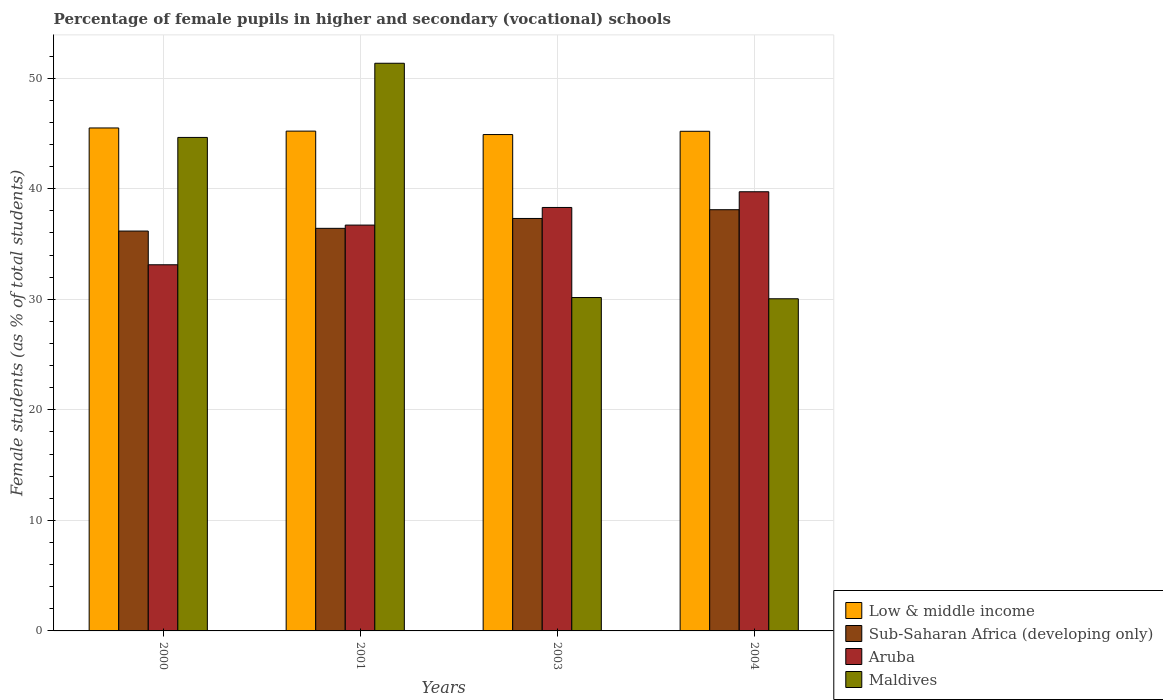How many groups of bars are there?
Keep it short and to the point. 4. Are the number of bars on each tick of the X-axis equal?
Your answer should be very brief. Yes. How many bars are there on the 4th tick from the right?
Offer a terse response. 4. What is the percentage of female pupils in higher and secondary schools in Maldives in 2004?
Your response must be concise. 30.04. Across all years, what is the maximum percentage of female pupils in higher and secondary schools in Aruba?
Your answer should be compact. 39.72. Across all years, what is the minimum percentage of female pupils in higher and secondary schools in Sub-Saharan Africa (developing only)?
Offer a very short reply. 36.17. What is the total percentage of female pupils in higher and secondary schools in Aruba in the graph?
Provide a short and direct response. 147.86. What is the difference between the percentage of female pupils in higher and secondary schools in Aruba in 2003 and that in 2004?
Your response must be concise. -1.42. What is the difference between the percentage of female pupils in higher and secondary schools in Maldives in 2003 and the percentage of female pupils in higher and secondary schools in Sub-Saharan Africa (developing only) in 2001?
Give a very brief answer. -6.26. What is the average percentage of female pupils in higher and secondary schools in Low & middle income per year?
Offer a terse response. 45.2. In the year 2003, what is the difference between the percentage of female pupils in higher and secondary schools in Maldives and percentage of female pupils in higher and secondary schools in Aruba?
Offer a terse response. -8.15. What is the ratio of the percentage of female pupils in higher and secondary schools in Aruba in 2001 to that in 2004?
Offer a terse response. 0.92. What is the difference between the highest and the second highest percentage of female pupils in higher and secondary schools in Maldives?
Keep it short and to the point. 6.71. What is the difference between the highest and the lowest percentage of female pupils in higher and secondary schools in Low & middle income?
Provide a short and direct response. 0.6. Is the sum of the percentage of female pupils in higher and secondary schools in Sub-Saharan Africa (developing only) in 2000 and 2003 greater than the maximum percentage of female pupils in higher and secondary schools in Maldives across all years?
Offer a terse response. Yes. Is it the case that in every year, the sum of the percentage of female pupils in higher and secondary schools in Maldives and percentage of female pupils in higher and secondary schools in Sub-Saharan Africa (developing only) is greater than the sum of percentage of female pupils in higher and secondary schools in Aruba and percentage of female pupils in higher and secondary schools in Low & middle income?
Offer a very short reply. No. What does the 3rd bar from the left in 2003 represents?
Your response must be concise. Aruba. What does the 2nd bar from the right in 2001 represents?
Provide a succinct answer. Aruba. Is it the case that in every year, the sum of the percentage of female pupils in higher and secondary schools in Maldives and percentage of female pupils in higher and secondary schools in Low & middle income is greater than the percentage of female pupils in higher and secondary schools in Aruba?
Offer a terse response. Yes. How many years are there in the graph?
Provide a short and direct response. 4. Does the graph contain grids?
Make the answer very short. Yes. How many legend labels are there?
Make the answer very short. 4. How are the legend labels stacked?
Offer a very short reply. Vertical. What is the title of the graph?
Offer a terse response. Percentage of female pupils in higher and secondary (vocational) schools. What is the label or title of the X-axis?
Keep it short and to the point. Years. What is the label or title of the Y-axis?
Offer a very short reply. Female students (as % of total students). What is the Female students (as % of total students) of Low & middle income in 2000?
Your answer should be compact. 45.5. What is the Female students (as % of total students) in Sub-Saharan Africa (developing only) in 2000?
Provide a short and direct response. 36.17. What is the Female students (as % of total students) in Aruba in 2000?
Ensure brevity in your answer.  33.12. What is the Female students (as % of total students) in Maldives in 2000?
Provide a short and direct response. 44.64. What is the Female students (as % of total students) in Low & middle income in 2001?
Provide a short and direct response. 45.21. What is the Female students (as % of total students) in Sub-Saharan Africa (developing only) in 2001?
Offer a terse response. 36.42. What is the Female students (as % of total students) in Aruba in 2001?
Provide a succinct answer. 36.71. What is the Female students (as % of total students) of Maldives in 2001?
Ensure brevity in your answer.  51.35. What is the Female students (as % of total students) in Low & middle income in 2003?
Offer a very short reply. 44.9. What is the Female students (as % of total students) of Sub-Saharan Africa (developing only) in 2003?
Provide a short and direct response. 37.31. What is the Female students (as % of total students) of Aruba in 2003?
Your answer should be very brief. 38.3. What is the Female students (as % of total students) in Maldives in 2003?
Offer a terse response. 30.16. What is the Female students (as % of total students) in Low & middle income in 2004?
Offer a very short reply. 45.19. What is the Female students (as % of total students) in Sub-Saharan Africa (developing only) in 2004?
Offer a very short reply. 38.1. What is the Female students (as % of total students) in Aruba in 2004?
Give a very brief answer. 39.72. What is the Female students (as % of total students) in Maldives in 2004?
Give a very brief answer. 30.04. Across all years, what is the maximum Female students (as % of total students) in Low & middle income?
Your answer should be very brief. 45.5. Across all years, what is the maximum Female students (as % of total students) in Sub-Saharan Africa (developing only)?
Your response must be concise. 38.1. Across all years, what is the maximum Female students (as % of total students) of Aruba?
Ensure brevity in your answer.  39.72. Across all years, what is the maximum Female students (as % of total students) of Maldives?
Your response must be concise. 51.35. Across all years, what is the minimum Female students (as % of total students) in Low & middle income?
Your answer should be very brief. 44.9. Across all years, what is the minimum Female students (as % of total students) in Sub-Saharan Africa (developing only)?
Give a very brief answer. 36.17. Across all years, what is the minimum Female students (as % of total students) of Aruba?
Offer a very short reply. 33.12. Across all years, what is the minimum Female students (as % of total students) of Maldives?
Offer a terse response. 30.04. What is the total Female students (as % of total students) in Low & middle income in the graph?
Offer a terse response. 180.8. What is the total Female students (as % of total students) in Sub-Saharan Africa (developing only) in the graph?
Provide a succinct answer. 147.99. What is the total Female students (as % of total students) in Aruba in the graph?
Your answer should be compact. 147.86. What is the total Female students (as % of total students) in Maldives in the graph?
Your response must be concise. 156.19. What is the difference between the Female students (as % of total students) in Low & middle income in 2000 and that in 2001?
Ensure brevity in your answer.  0.29. What is the difference between the Female students (as % of total students) of Sub-Saharan Africa (developing only) in 2000 and that in 2001?
Your response must be concise. -0.25. What is the difference between the Female students (as % of total students) in Aruba in 2000 and that in 2001?
Your answer should be very brief. -3.59. What is the difference between the Female students (as % of total students) of Maldives in 2000 and that in 2001?
Your answer should be compact. -6.71. What is the difference between the Female students (as % of total students) of Low & middle income in 2000 and that in 2003?
Your response must be concise. 0.6. What is the difference between the Female students (as % of total students) of Sub-Saharan Africa (developing only) in 2000 and that in 2003?
Your response must be concise. -1.14. What is the difference between the Female students (as % of total students) in Aruba in 2000 and that in 2003?
Your response must be concise. -5.18. What is the difference between the Female students (as % of total students) of Maldives in 2000 and that in 2003?
Your answer should be very brief. 14.48. What is the difference between the Female students (as % of total students) in Low & middle income in 2000 and that in 2004?
Give a very brief answer. 0.3. What is the difference between the Female students (as % of total students) of Sub-Saharan Africa (developing only) in 2000 and that in 2004?
Your answer should be very brief. -1.93. What is the difference between the Female students (as % of total students) of Aruba in 2000 and that in 2004?
Keep it short and to the point. -6.6. What is the difference between the Female students (as % of total students) of Maldives in 2000 and that in 2004?
Provide a succinct answer. 14.59. What is the difference between the Female students (as % of total students) in Low & middle income in 2001 and that in 2003?
Offer a terse response. 0.31. What is the difference between the Female students (as % of total students) in Sub-Saharan Africa (developing only) in 2001 and that in 2003?
Your response must be concise. -0.89. What is the difference between the Female students (as % of total students) of Aruba in 2001 and that in 2003?
Provide a short and direct response. -1.59. What is the difference between the Female students (as % of total students) of Maldives in 2001 and that in 2003?
Your response must be concise. 21.19. What is the difference between the Female students (as % of total students) in Low & middle income in 2001 and that in 2004?
Ensure brevity in your answer.  0.02. What is the difference between the Female students (as % of total students) of Sub-Saharan Africa (developing only) in 2001 and that in 2004?
Provide a succinct answer. -1.68. What is the difference between the Female students (as % of total students) of Aruba in 2001 and that in 2004?
Keep it short and to the point. -3.01. What is the difference between the Female students (as % of total students) in Maldives in 2001 and that in 2004?
Your answer should be compact. 21.3. What is the difference between the Female students (as % of total students) of Low & middle income in 2003 and that in 2004?
Keep it short and to the point. -0.29. What is the difference between the Female students (as % of total students) of Sub-Saharan Africa (developing only) in 2003 and that in 2004?
Offer a very short reply. -0.79. What is the difference between the Female students (as % of total students) in Aruba in 2003 and that in 2004?
Ensure brevity in your answer.  -1.42. What is the difference between the Female students (as % of total students) in Maldives in 2003 and that in 2004?
Keep it short and to the point. 0.11. What is the difference between the Female students (as % of total students) in Low & middle income in 2000 and the Female students (as % of total students) in Sub-Saharan Africa (developing only) in 2001?
Make the answer very short. 9.08. What is the difference between the Female students (as % of total students) of Low & middle income in 2000 and the Female students (as % of total students) of Aruba in 2001?
Keep it short and to the point. 8.79. What is the difference between the Female students (as % of total students) in Low & middle income in 2000 and the Female students (as % of total students) in Maldives in 2001?
Offer a very short reply. -5.85. What is the difference between the Female students (as % of total students) of Sub-Saharan Africa (developing only) in 2000 and the Female students (as % of total students) of Aruba in 2001?
Provide a succinct answer. -0.54. What is the difference between the Female students (as % of total students) of Sub-Saharan Africa (developing only) in 2000 and the Female students (as % of total students) of Maldives in 2001?
Provide a short and direct response. -15.18. What is the difference between the Female students (as % of total students) in Aruba in 2000 and the Female students (as % of total students) in Maldives in 2001?
Your answer should be very brief. -18.23. What is the difference between the Female students (as % of total students) of Low & middle income in 2000 and the Female students (as % of total students) of Sub-Saharan Africa (developing only) in 2003?
Your answer should be very brief. 8.19. What is the difference between the Female students (as % of total students) in Low & middle income in 2000 and the Female students (as % of total students) in Aruba in 2003?
Provide a succinct answer. 7.19. What is the difference between the Female students (as % of total students) in Low & middle income in 2000 and the Female students (as % of total students) in Maldives in 2003?
Provide a succinct answer. 15.34. What is the difference between the Female students (as % of total students) in Sub-Saharan Africa (developing only) in 2000 and the Female students (as % of total students) in Aruba in 2003?
Your answer should be compact. -2.13. What is the difference between the Female students (as % of total students) of Sub-Saharan Africa (developing only) in 2000 and the Female students (as % of total students) of Maldives in 2003?
Your answer should be very brief. 6.01. What is the difference between the Female students (as % of total students) of Aruba in 2000 and the Female students (as % of total students) of Maldives in 2003?
Offer a very short reply. 2.96. What is the difference between the Female students (as % of total students) of Low & middle income in 2000 and the Female students (as % of total students) of Sub-Saharan Africa (developing only) in 2004?
Ensure brevity in your answer.  7.39. What is the difference between the Female students (as % of total students) in Low & middle income in 2000 and the Female students (as % of total students) in Aruba in 2004?
Your response must be concise. 5.77. What is the difference between the Female students (as % of total students) in Low & middle income in 2000 and the Female students (as % of total students) in Maldives in 2004?
Offer a very short reply. 15.45. What is the difference between the Female students (as % of total students) in Sub-Saharan Africa (developing only) in 2000 and the Female students (as % of total students) in Aruba in 2004?
Your answer should be compact. -3.56. What is the difference between the Female students (as % of total students) of Sub-Saharan Africa (developing only) in 2000 and the Female students (as % of total students) of Maldives in 2004?
Provide a succinct answer. 6.12. What is the difference between the Female students (as % of total students) of Aruba in 2000 and the Female students (as % of total students) of Maldives in 2004?
Your answer should be very brief. 3.08. What is the difference between the Female students (as % of total students) of Low & middle income in 2001 and the Female students (as % of total students) of Sub-Saharan Africa (developing only) in 2003?
Your response must be concise. 7.9. What is the difference between the Female students (as % of total students) in Low & middle income in 2001 and the Female students (as % of total students) in Aruba in 2003?
Your answer should be compact. 6.91. What is the difference between the Female students (as % of total students) in Low & middle income in 2001 and the Female students (as % of total students) in Maldives in 2003?
Provide a short and direct response. 15.05. What is the difference between the Female students (as % of total students) of Sub-Saharan Africa (developing only) in 2001 and the Female students (as % of total students) of Aruba in 2003?
Provide a succinct answer. -1.89. What is the difference between the Female students (as % of total students) in Sub-Saharan Africa (developing only) in 2001 and the Female students (as % of total students) in Maldives in 2003?
Provide a succinct answer. 6.26. What is the difference between the Female students (as % of total students) of Aruba in 2001 and the Female students (as % of total students) of Maldives in 2003?
Your response must be concise. 6.55. What is the difference between the Female students (as % of total students) of Low & middle income in 2001 and the Female students (as % of total students) of Sub-Saharan Africa (developing only) in 2004?
Your answer should be compact. 7.11. What is the difference between the Female students (as % of total students) of Low & middle income in 2001 and the Female students (as % of total students) of Aruba in 2004?
Give a very brief answer. 5.49. What is the difference between the Female students (as % of total students) in Low & middle income in 2001 and the Female students (as % of total students) in Maldives in 2004?
Make the answer very short. 15.17. What is the difference between the Female students (as % of total students) in Sub-Saharan Africa (developing only) in 2001 and the Female students (as % of total students) in Aruba in 2004?
Ensure brevity in your answer.  -3.31. What is the difference between the Female students (as % of total students) in Sub-Saharan Africa (developing only) in 2001 and the Female students (as % of total students) in Maldives in 2004?
Keep it short and to the point. 6.37. What is the difference between the Female students (as % of total students) in Aruba in 2001 and the Female students (as % of total students) in Maldives in 2004?
Keep it short and to the point. 6.67. What is the difference between the Female students (as % of total students) in Low & middle income in 2003 and the Female students (as % of total students) in Sub-Saharan Africa (developing only) in 2004?
Keep it short and to the point. 6.8. What is the difference between the Female students (as % of total students) in Low & middle income in 2003 and the Female students (as % of total students) in Aruba in 2004?
Give a very brief answer. 5.17. What is the difference between the Female students (as % of total students) of Low & middle income in 2003 and the Female students (as % of total students) of Maldives in 2004?
Offer a terse response. 14.85. What is the difference between the Female students (as % of total students) of Sub-Saharan Africa (developing only) in 2003 and the Female students (as % of total students) of Aruba in 2004?
Your answer should be compact. -2.42. What is the difference between the Female students (as % of total students) of Sub-Saharan Africa (developing only) in 2003 and the Female students (as % of total students) of Maldives in 2004?
Offer a terse response. 7.26. What is the difference between the Female students (as % of total students) of Aruba in 2003 and the Female students (as % of total students) of Maldives in 2004?
Provide a succinct answer. 8.26. What is the average Female students (as % of total students) in Low & middle income per year?
Provide a succinct answer. 45.2. What is the average Female students (as % of total students) of Sub-Saharan Africa (developing only) per year?
Make the answer very short. 37. What is the average Female students (as % of total students) of Aruba per year?
Provide a succinct answer. 36.96. What is the average Female students (as % of total students) in Maldives per year?
Offer a very short reply. 39.05. In the year 2000, what is the difference between the Female students (as % of total students) of Low & middle income and Female students (as % of total students) of Sub-Saharan Africa (developing only)?
Make the answer very short. 9.33. In the year 2000, what is the difference between the Female students (as % of total students) in Low & middle income and Female students (as % of total students) in Aruba?
Your answer should be compact. 12.38. In the year 2000, what is the difference between the Female students (as % of total students) in Low & middle income and Female students (as % of total students) in Maldives?
Provide a succinct answer. 0.86. In the year 2000, what is the difference between the Female students (as % of total students) of Sub-Saharan Africa (developing only) and Female students (as % of total students) of Aruba?
Keep it short and to the point. 3.05. In the year 2000, what is the difference between the Female students (as % of total students) in Sub-Saharan Africa (developing only) and Female students (as % of total students) in Maldives?
Provide a succinct answer. -8.47. In the year 2000, what is the difference between the Female students (as % of total students) of Aruba and Female students (as % of total students) of Maldives?
Your response must be concise. -11.52. In the year 2001, what is the difference between the Female students (as % of total students) of Low & middle income and Female students (as % of total students) of Sub-Saharan Africa (developing only)?
Your answer should be compact. 8.79. In the year 2001, what is the difference between the Female students (as % of total students) of Low & middle income and Female students (as % of total students) of Aruba?
Provide a succinct answer. 8.5. In the year 2001, what is the difference between the Female students (as % of total students) in Low & middle income and Female students (as % of total students) in Maldives?
Provide a short and direct response. -6.14. In the year 2001, what is the difference between the Female students (as % of total students) of Sub-Saharan Africa (developing only) and Female students (as % of total students) of Aruba?
Your answer should be very brief. -0.29. In the year 2001, what is the difference between the Female students (as % of total students) of Sub-Saharan Africa (developing only) and Female students (as % of total students) of Maldives?
Your response must be concise. -14.93. In the year 2001, what is the difference between the Female students (as % of total students) in Aruba and Female students (as % of total students) in Maldives?
Offer a terse response. -14.64. In the year 2003, what is the difference between the Female students (as % of total students) in Low & middle income and Female students (as % of total students) in Sub-Saharan Africa (developing only)?
Your answer should be very brief. 7.59. In the year 2003, what is the difference between the Female students (as % of total students) of Low & middle income and Female students (as % of total students) of Aruba?
Your response must be concise. 6.59. In the year 2003, what is the difference between the Female students (as % of total students) in Low & middle income and Female students (as % of total students) in Maldives?
Your answer should be very brief. 14.74. In the year 2003, what is the difference between the Female students (as % of total students) of Sub-Saharan Africa (developing only) and Female students (as % of total students) of Aruba?
Your answer should be compact. -1. In the year 2003, what is the difference between the Female students (as % of total students) in Sub-Saharan Africa (developing only) and Female students (as % of total students) in Maldives?
Give a very brief answer. 7.15. In the year 2003, what is the difference between the Female students (as % of total students) in Aruba and Female students (as % of total students) in Maldives?
Keep it short and to the point. 8.15. In the year 2004, what is the difference between the Female students (as % of total students) of Low & middle income and Female students (as % of total students) of Sub-Saharan Africa (developing only)?
Offer a terse response. 7.09. In the year 2004, what is the difference between the Female students (as % of total students) in Low & middle income and Female students (as % of total students) in Aruba?
Your answer should be very brief. 5.47. In the year 2004, what is the difference between the Female students (as % of total students) in Low & middle income and Female students (as % of total students) in Maldives?
Give a very brief answer. 15.15. In the year 2004, what is the difference between the Female students (as % of total students) of Sub-Saharan Africa (developing only) and Female students (as % of total students) of Aruba?
Your response must be concise. -1.62. In the year 2004, what is the difference between the Female students (as % of total students) in Sub-Saharan Africa (developing only) and Female students (as % of total students) in Maldives?
Provide a short and direct response. 8.06. In the year 2004, what is the difference between the Female students (as % of total students) in Aruba and Female students (as % of total students) in Maldives?
Offer a terse response. 9.68. What is the ratio of the Female students (as % of total students) in Low & middle income in 2000 to that in 2001?
Ensure brevity in your answer.  1.01. What is the ratio of the Female students (as % of total students) in Aruba in 2000 to that in 2001?
Your answer should be very brief. 0.9. What is the ratio of the Female students (as % of total students) of Maldives in 2000 to that in 2001?
Your response must be concise. 0.87. What is the ratio of the Female students (as % of total students) of Low & middle income in 2000 to that in 2003?
Provide a short and direct response. 1.01. What is the ratio of the Female students (as % of total students) of Sub-Saharan Africa (developing only) in 2000 to that in 2003?
Your response must be concise. 0.97. What is the ratio of the Female students (as % of total students) in Aruba in 2000 to that in 2003?
Your answer should be compact. 0.86. What is the ratio of the Female students (as % of total students) in Maldives in 2000 to that in 2003?
Offer a terse response. 1.48. What is the ratio of the Female students (as % of total students) of Low & middle income in 2000 to that in 2004?
Ensure brevity in your answer.  1.01. What is the ratio of the Female students (as % of total students) in Sub-Saharan Africa (developing only) in 2000 to that in 2004?
Provide a succinct answer. 0.95. What is the ratio of the Female students (as % of total students) in Aruba in 2000 to that in 2004?
Provide a succinct answer. 0.83. What is the ratio of the Female students (as % of total students) in Maldives in 2000 to that in 2004?
Keep it short and to the point. 1.49. What is the ratio of the Female students (as % of total students) in Sub-Saharan Africa (developing only) in 2001 to that in 2003?
Ensure brevity in your answer.  0.98. What is the ratio of the Female students (as % of total students) of Aruba in 2001 to that in 2003?
Your answer should be compact. 0.96. What is the ratio of the Female students (as % of total students) in Maldives in 2001 to that in 2003?
Make the answer very short. 1.7. What is the ratio of the Female students (as % of total students) in Sub-Saharan Africa (developing only) in 2001 to that in 2004?
Your response must be concise. 0.96. What is the ratio of the Female students (as % of total students) in Aruba in 2001 to that in 2004?
Provide a short and direct response. 0.92. What is the ratio of the Female students (as % of total students) of Maldives in 2001 to that in 2004?
Offer a very short reply. 1.71. What is the ratio of the Female students (as % of total students) in Sub-Saharan Africa (developing only) in 2003 to that in 2004?
Offer a terse response. 0.98. What is the ratio of the Female students (as % of total students) in Aruba in 2003 to that in 2004?
Keep it short and to the point. 0.96. What is the difference between the highest and the second highest Female students (as % of total students) in Low & middle income?
Ensure brevity in your answer.  0.29. What is the difference between the highest and the second highest Female students (as % of total students) in Sub-Saharan Africa (developing only)?
Offer a terse response. 0.79. What is the difference between the highest and the second highest Female students (as % of total students) of Aruba?
Provide a short and direct response. 1.42. What is the difference between the highest and the second highest Female students (as % of total students) in Maldives?
Your response must be concise. 6.71. What is the difference between the highest and the lowest Female students (as % of total students) in Low & middle income?
Your answer should be very brief. 0.6. What is the difference between the highest and the lowest Female students (as % of total students) of Sub-Saharan Africa (developing only)?
Make the answer very short. 1.93. What is the difference between the highest and the lowest Female students (as % of total students) in Aruba?
Your answer should be compact. 6.6. What is the difference between the highest and the lowest Female students (as % of total students) in Maldives?
Make the answer very short. 21.3. 